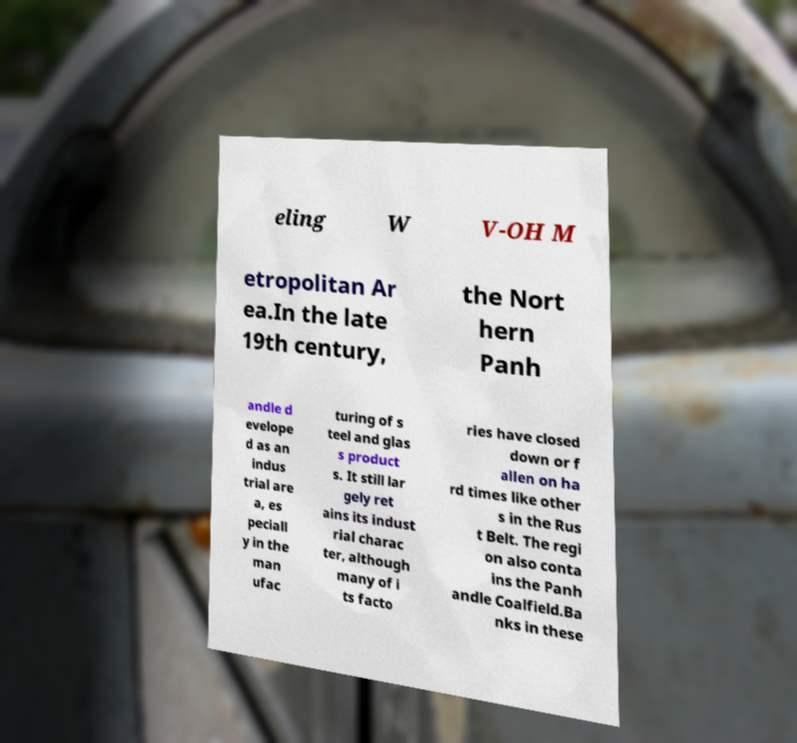Could you assist in decoding the text presented in this image and type it out clearly? eling W V-OH M etropolitan Ar ea.In the late 19th century, the Nort hern Panh andle d evelope d as an indus trial are a, es peciall y in the man ufac turing of s teel and glas s product s. It still lar gely ret ains its indust rial charac ter, although many of i ts facto ries have closed down or f allen on ha rd times like other s in the Rus t Belt. The regi on also conta ins the Panh andle Coalfield.Ba nks in these 